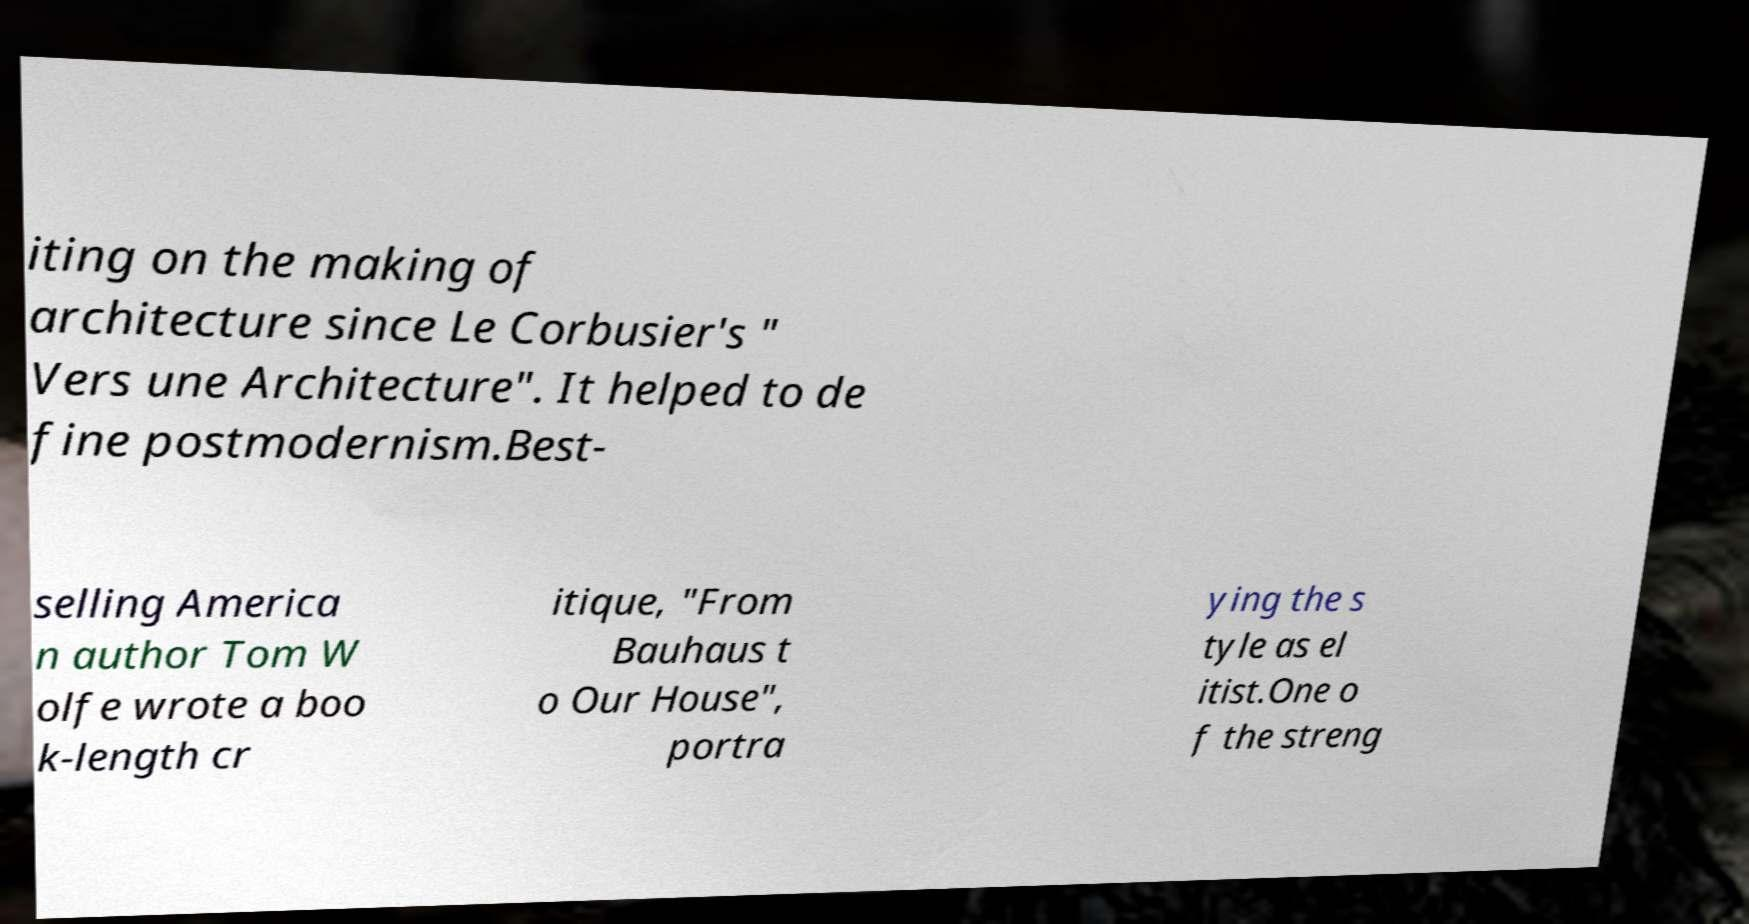Can you read and provide the text displayed in the image?This photo seems to have some interesting text. Can you extract and type it out for me? iting on the making of architecture since Le Corbusier's " Vers une Architecture". It helped to de fine postmodernism.Best- selling America n author Tom W olfe wrote a boo k-length cr itique, "From Bauhaus t o Our House", portra ying the s tyle as el itist.One o f the streng 